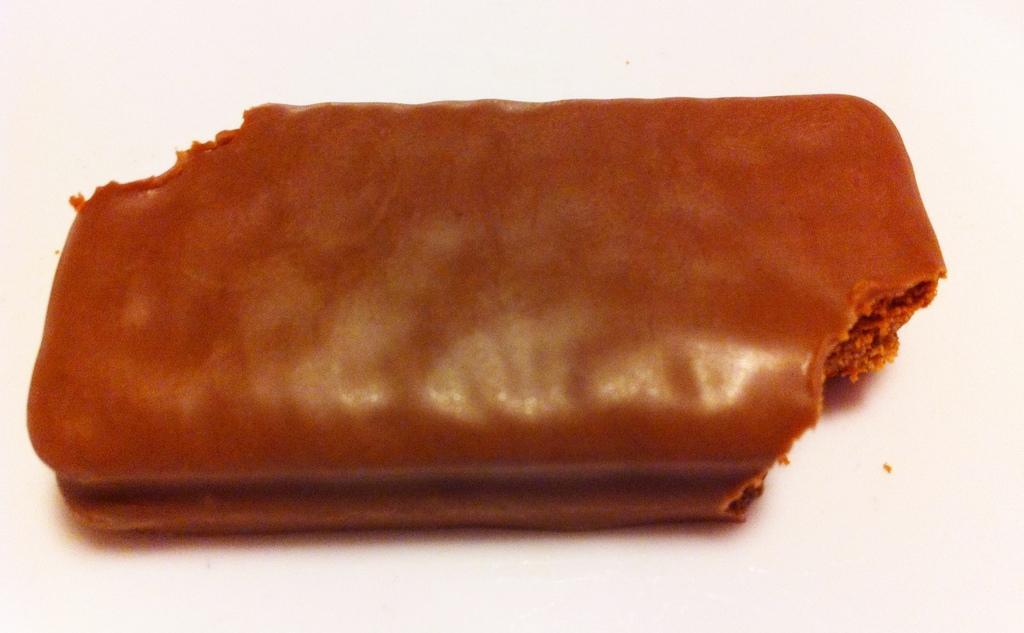Can you describe this image briefly? In this given image, I can see a half eaten chocolate. 